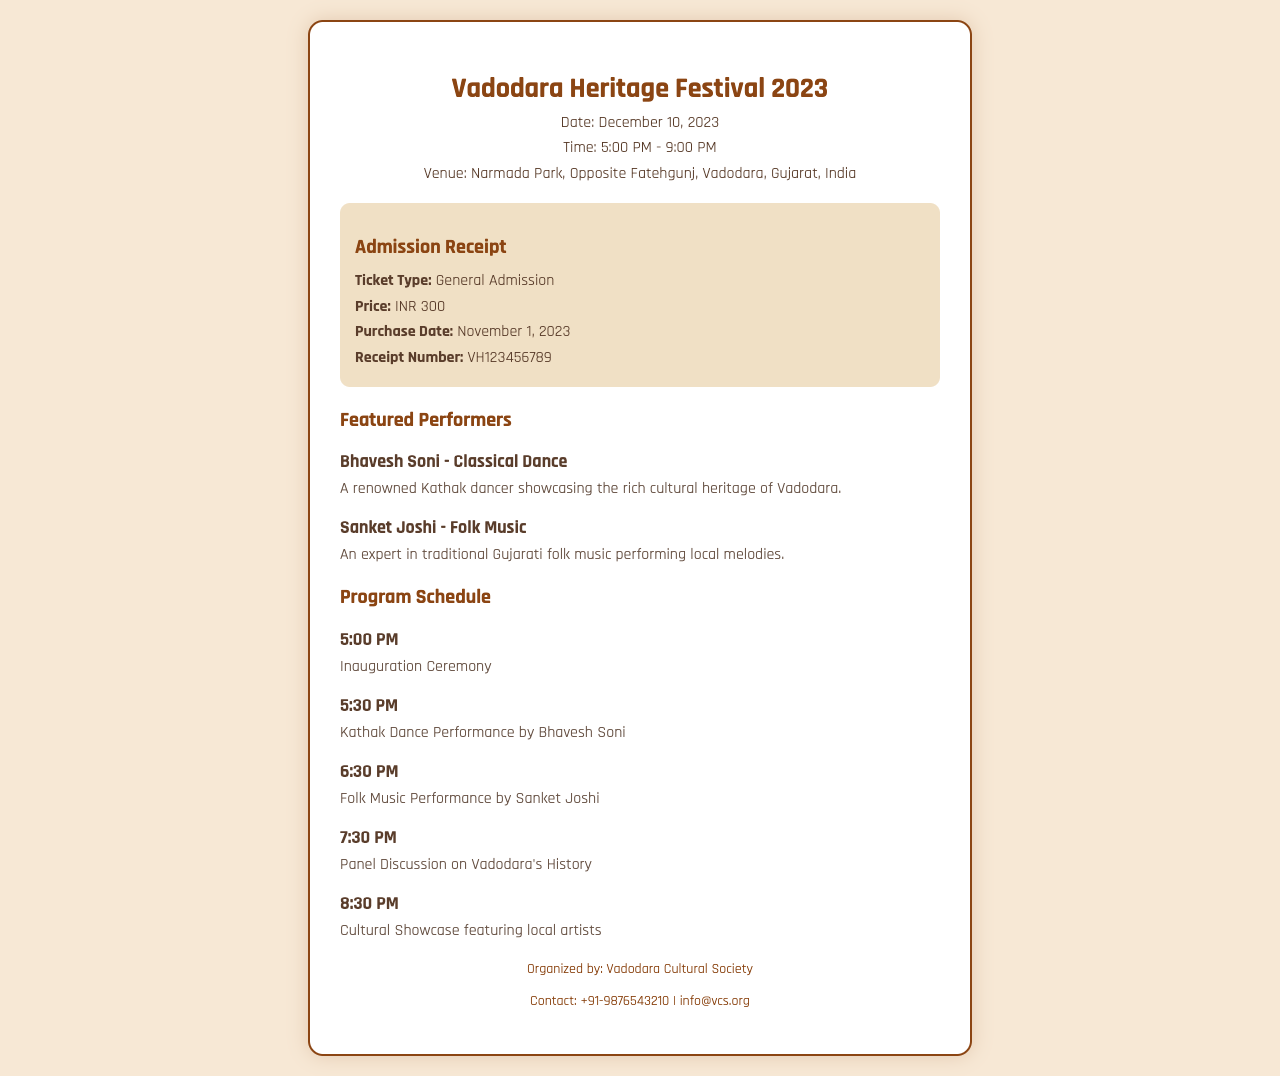What is the event date? The date of the Vadodara Heritage Festival is mentioned as December 10, 2023.
Answer: December 10, 2023 What type of ticket is issued? The ticket type for the admission receipt is specified under "Ticket Type" as General Admission.
Answer: General Admission What is the price of the ticket? The Price of the ticket is given in the document as INR 300.
Answer: INR 300 Who is the performer for the Kathak Dance? The document lists Bhavesh Soni as the performer for the Kathak Dance performance.
Answer: Bhavesh Soni At what time does the Folk Music Performance start? The Folk Music Performance by Sanket Joshi is scheduled to start at 6:30 PM.
Answer: 6:30 PM How many featured performers are mentioned? The document provides details about two featured performers in total.
Answer: Two What is the contact number provided for inquiries? The contact number for the Vadodara Cultural Society is stated as +91-9876543210.
Answer: +91-9876543210 What organization is responsible for organizing the event? The organized entity for the event is mentioned as Vadodara Cultural Society.
Answer: Vadodara Cultural Society 